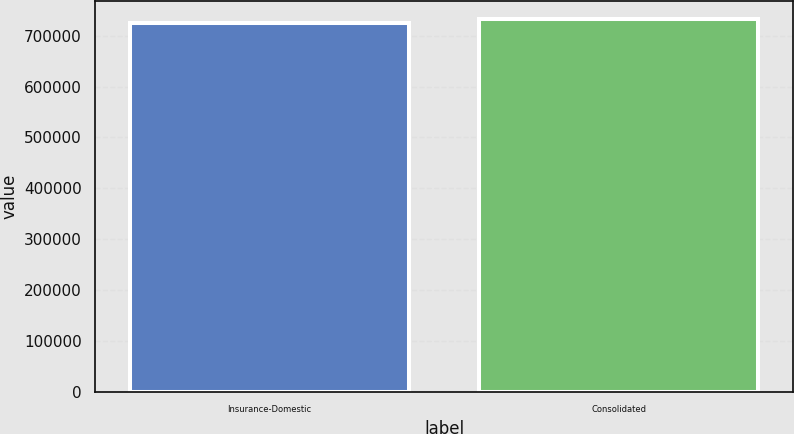Convert chart. <chart><loc_0><loc_0><loc_500><loc_500><bar_chart><fcel>Insurance-Domestic<fcel>Consolidated<nl><fcel>724667<fcel>732030<nl></chart> 